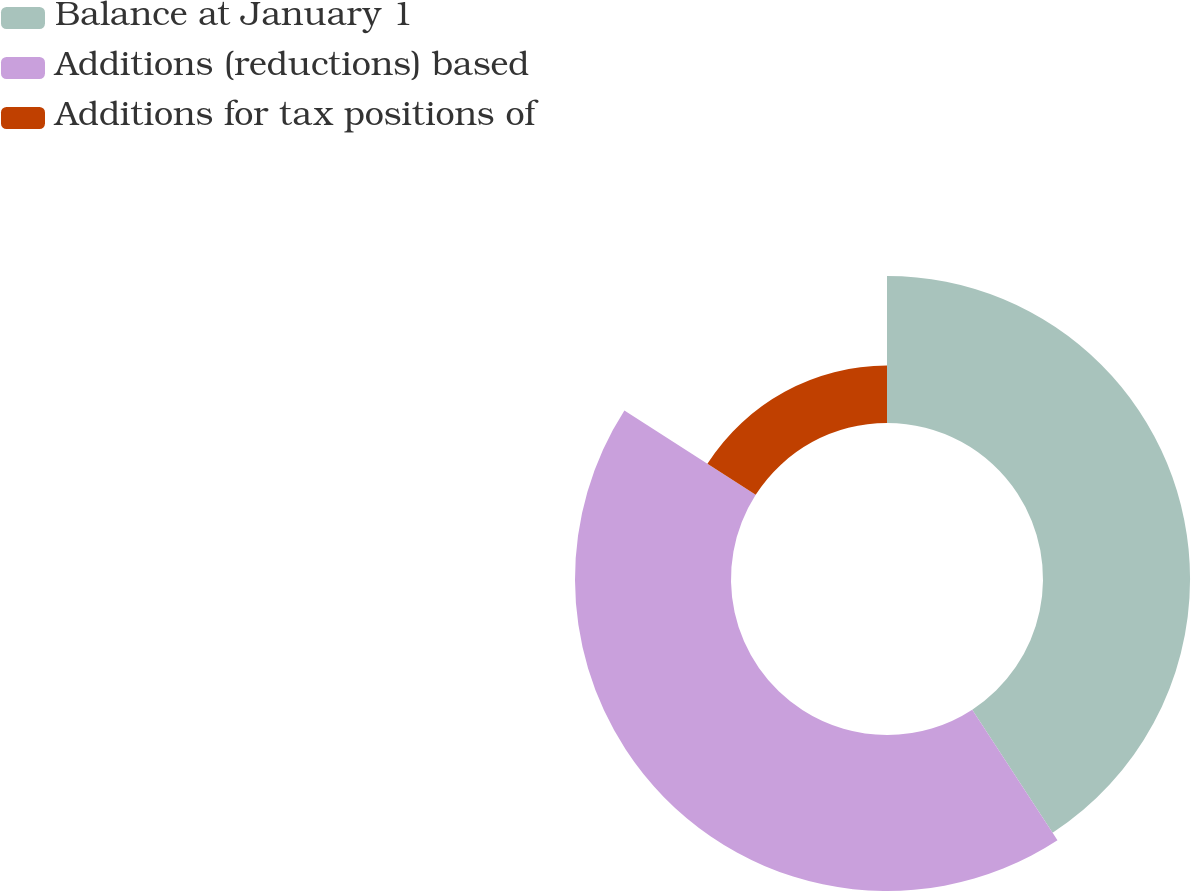Convert chart. <chart><loc_0><loc_0><loc_500><loc_500><pie_chart><fcel>Balance at January 1<fcel>Additions (reductions) based<fcel>Additions for tax positions of<nl><fcel>40.8%<fcel>43.28%<fcel>15.92%<nl></chart> 